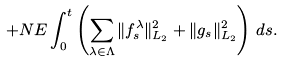<formula> <loc_0><loc_0><loc_500><loc_500>+ N E \int _ { 0 } ^ { t } \left ( \sum _ { \lambda \in \Lambda } \| f ^ { \lambda } _ { s } \| ^ { 2 } _ { L _ { 2 } } + \| g _ { s } \| ^ { 2 } _ { L _ { 2 } } \right ) \, d s .</formula> 